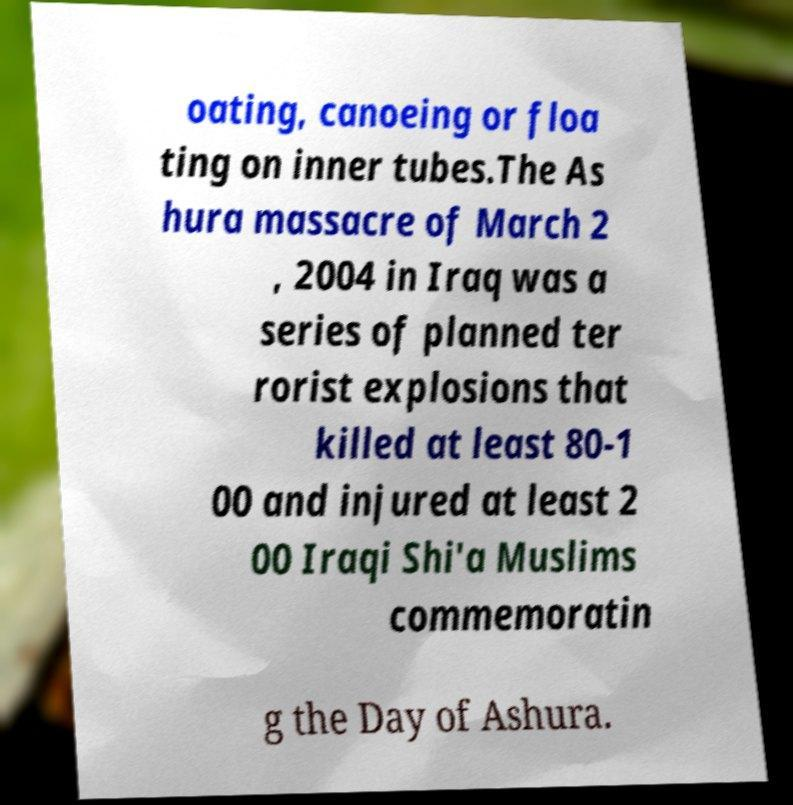For documentation purposes, I need the text within this image transcribed. Could you provide that? oating, canoeing or floa ting on inner tubes.The As hura massacre of March 2 , 2004 in Iraq was a series of planned ter rorist explosions that killed at least 80-1 00 and injured at least 2 00 Iraqi Shi'a Muslims commemoratin g the Day of Ashura. 